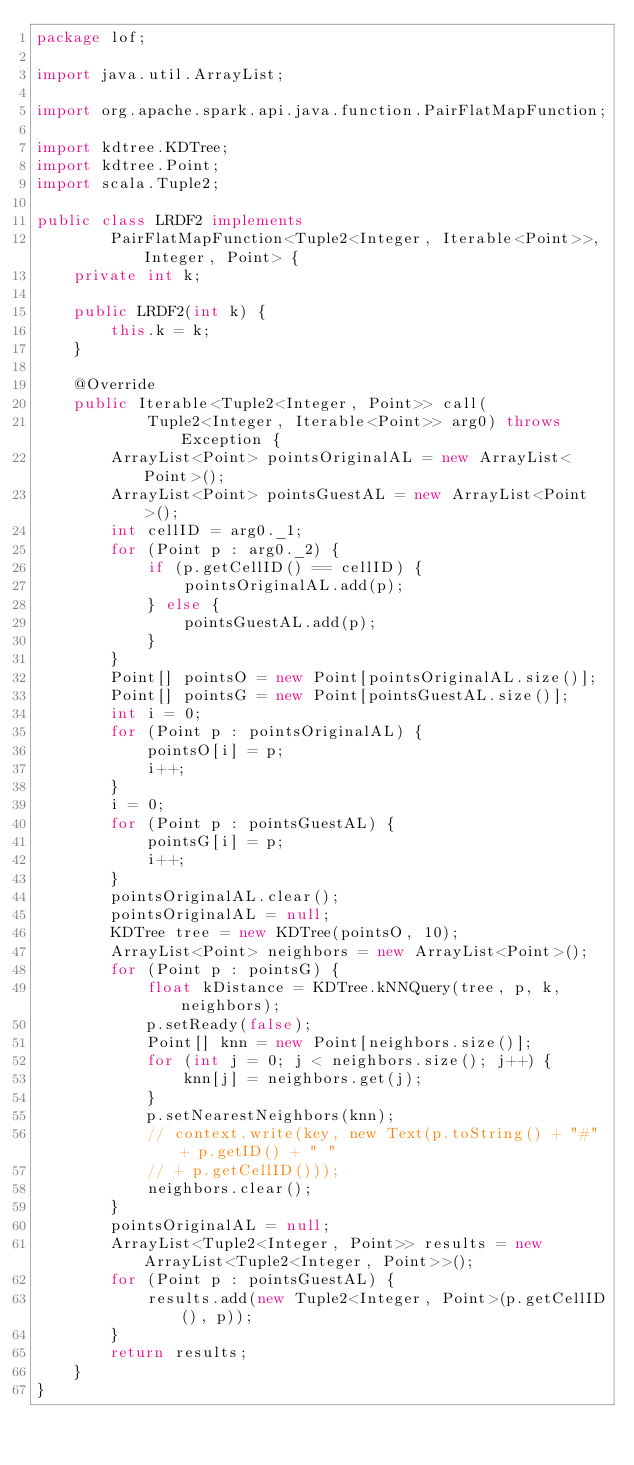Convert code to text. <code><loc_0><loc_0><loc_500><loc_500><_Java_>package lof;

import java.util.ArrayList;

import org.apache.spark.api.java.function.PairFlatMapFunction;

import kdtree.KDTree;
import kdtree.Point;
import scala.Tuple2;

public class LRDF2 implements
		PairFlatMapFunction<Tuple2<Integer, Iterable<Point>>, Integer, Point> {
	private int k;

	public LRDF2(int k) {
		this.k = k;
	}

	@Override
	public Iterable<Tuple2<Integer, Point>> call(
			Tuple2<Integer, Iterable<Point>> arg0) throws Exception {
		ArrayList<Point> pointsOriginalAL = new ArrayList<Point>();
		ArrayList<Point> pointsGuestAL = new ArrayList<Point>();
		int cellID = arg0._1;
		for (Point p : arg0._2) {
			if (p.getCellID() == cellID) {
				pointsOriginalAL.add(p);
			} else {
				pointsGuestAL.add(p);
			}
		}
		Point[] pointsO = new Point[pointsOriginalAL.size()];
		Point[] pointsG = new Point[pointsGuestAL.size()];
		int i = 0;
		for (Point p : pointsOriginalAL) {
			pointsO[i] = p;
			i++;
		}
		i = 0;
		for (Point p : pointsGuestAL) {
			pointsG[i] = p;
			i++;
		}
		pointsOriginalAL.clear();
		pointsOriginalAL = null;
		KDTree tree = new KDTree(pointsO, 10);
		ArrayList<Point> neighbors = new ArrayList<Point>();
		for (Point p : pointsG) {
			float kDistance = KDTree.kNNQuery(tree, p, k, neighbors);
			p.setReady(false);
			Point[] knn = new Point[neighbors.size()];
			for (int j = 0; j < neighbors.size(); j++) {
				knn[j] = neighbors.get(j);
			}
			p.setNearestNeighbors(knn);
			// context.write(key, new Text(p.toString() + "#" + p.getID() + " "
			// + p.getCellID()));
			neighbors.clear();
		}
		pointsOriginalAL = null;
		ArrayList<Tuple2<Integer, Point>> results = new ArrayList<Tuple2<Integer, Point>>();
		for (Point p : pointsGuestAL) {
			results.add(new Tuple2<Integer, Point>(p.getCellID(), p));
		}
		return results;
	}
}
</code> 